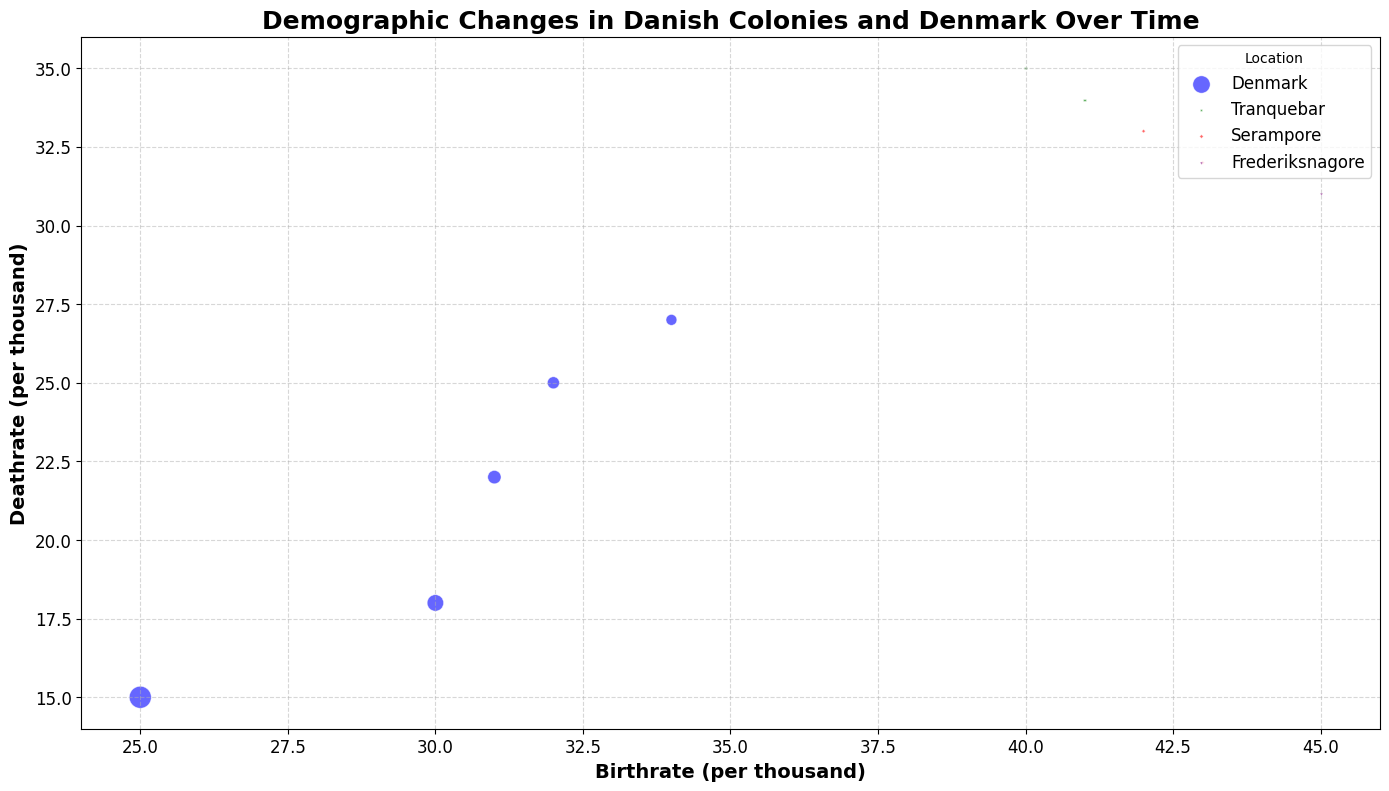What is the location with the highest death rate in 1800? To find the location with the highest death rate in 1800, locate the year 1800 in the data points. Compare the death rates for Denmark and Serampore. Serampore has a death rate of 33.0, which is higher than Denmark's 22.0.
Answer: Serampore How does the population of Denmark compare to Tranquebar in 1701? Look at the population sizes for both locations in 1701. Denmark has a population of 610,000 while Tranquebar has 25,000. Denmark's population is significantly larger.
Answer: Denmark is significantly larger Which location experienced the highest birth rate in the data set? Check all birth rates for Tranquebar, Serampore, and Frederiksnagore. Compare them and see Frederiksnagore in 1900 has the highest birth rate at 45.0.
Answer: Frederiksnagore What is the average birth rate of Denmark over the years? Find birth rates of Denmark for all years (34.0, 32.0, 31.0, 30.0, 25.0). Sum these rates and divide by the number of years. (34.0 + 32.0 + 31.0 + 30.0 + 25.0)/5 = 30.4.
Answer: 30.4 How did the birth rate of Serampore in 1850 compare to Frederiksnagore in 1900? Look at both birth rates: Serampore in 1850 is 43.0 and Frederiksnagore in 1900 is 45.0. Frederiksnagore's birth rate is higher.
Answer: Frederiksnagore's is higher Which location showed the greatest decline in death rate from their earliest to latest recorded data points? Compare the changes in death rates: Denmark (27.0 to 15.0), Tranquebar (35.0 to 34.0), Serampore (33.0 to 32.0), Frederiksnagore (only one data point). Denmark shows the greatest decline.
Answer: Denmark What is the population difference between Denmark and Frederiksnagore in 1900? Population of Denmark in 1900 is 2,500,000, and Frederiksnagore is 45,000. Subtract the latter from the former to get the difference: 2,500,000 - 45,000 = 2,455,000.
Answer: 2,455,000 If we sum up the populations of all colonies in 1800, what is the total? Look at the populations of Tranquebar and Serampore in 1800. Sum them up: 0 (No Tranquebar data) + 35,000 = 35,000.
Answer: 35,000 By how much did Denmark's population increase from 1701 to 1800? Denmark's population in 1701 is 610,000 and in 1800 it is 920,000. Subtract the former from the latter: 920,000 - 610,000 = 310,000.
Answer: 310,000 